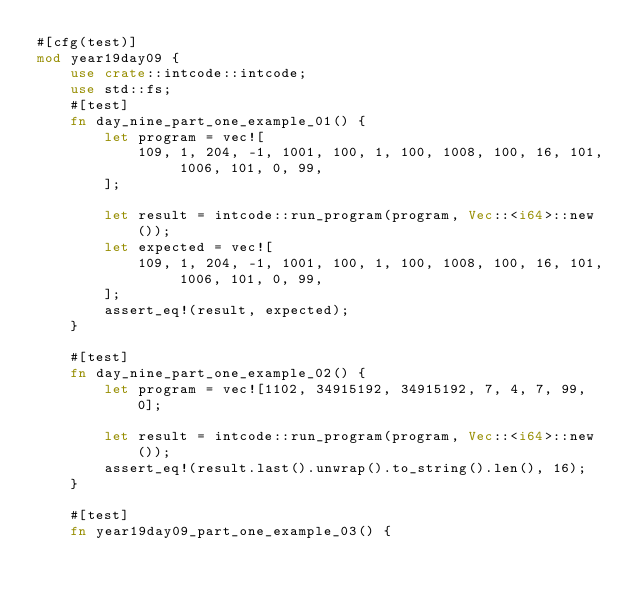Convert code to text. <code><loc_0><loc_0><loc_500><loc_500><_Rust_>#[cfg(test)]
mod year19day09 {
    use crate::intcode::intcode;
    use std::fs;
    #[test]
    fn day_nine_part_one_example_01() {
        let program = vec![
            109, 1, 204, -1, 1001, 100, 1, 100, 1008, 100, 16, 101, 1006, 101, 0, 99,
        ];

        let result = intcode::run_program(program, Vec::<i64>::new());
        let expected = vec![
            109, 1, 204, -1, 1001, 100, 1, 100, 1008, 100, 16, 101, 1006, 101, 0, 99,
        ];
        assert_eq!(result, expected);
    }

    #[test]
    fn day_nine_part_one_example_02() {
        let program = vec![1102, 34915192, 34915192, 7, 4, 7, 99, 0];

        let result = intcode::run_program(program, Vec::<i64>::new());
        assert_eq!(result.last().unwrap().to_string().len(), 16);
    }

    #[test]
    fn year19day09_part_one_example_03() {</code> 